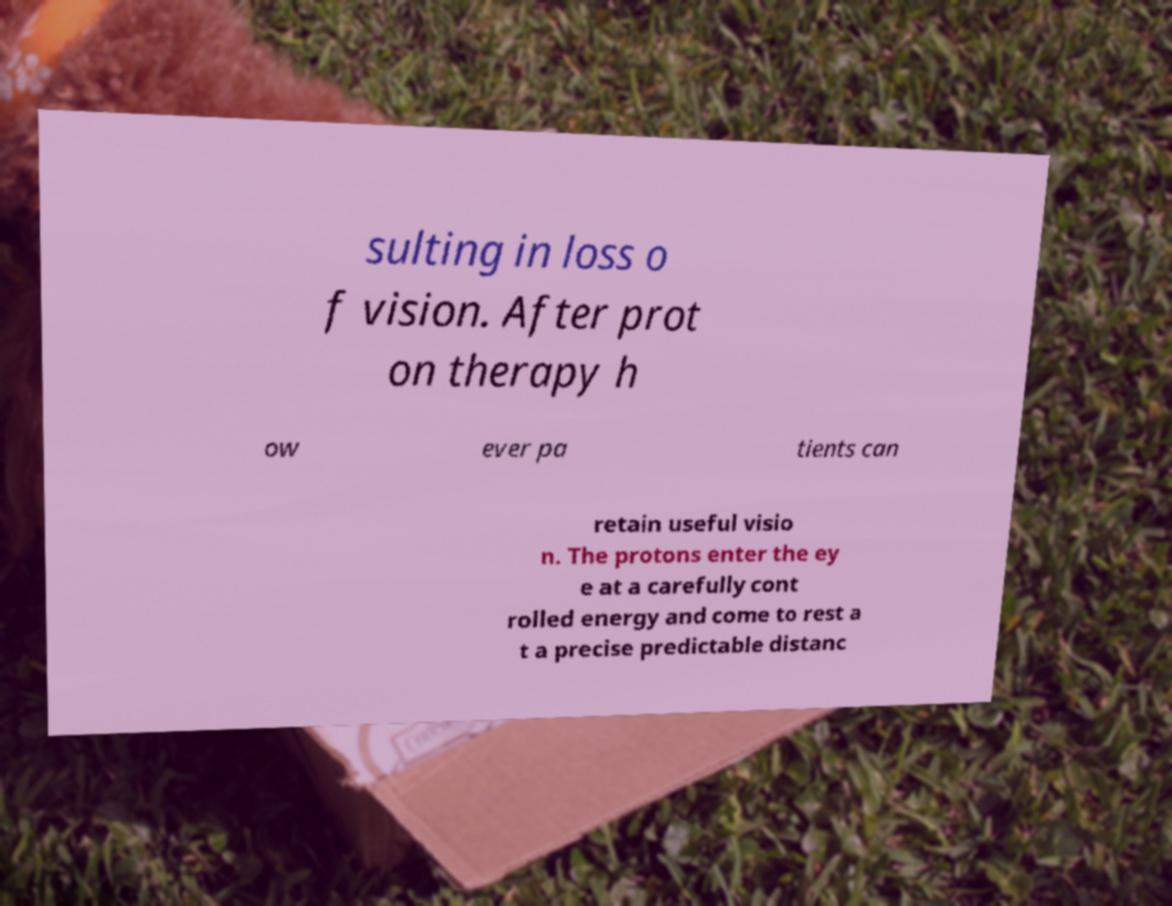Can you read and provide the text displayed in the image?This photo seems to have some interesting text. Can you extract and type it out for me? sulting in loss o f vision. After prot on therapy h ow ever pa tients can retain useful visio n. The protons enter the ey e at a carefully cont rolled energy and come to rest a t a precise predictable distanc 